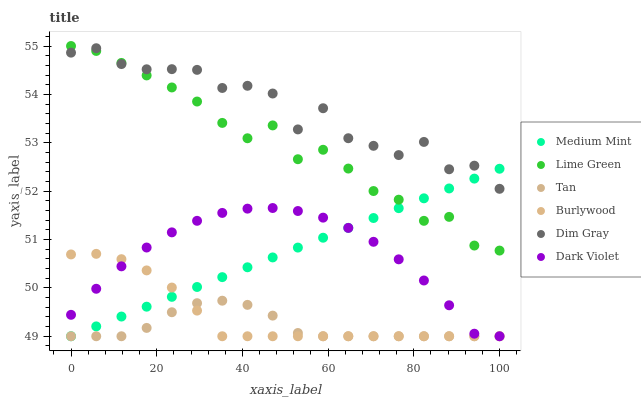Does Tan have the minimum area under the curve?
Answer yes or no. Yes. Does Dim Gray have the maximum area under the curve?
Answer yes or no. Yes. Does Burlywood have the minimum area under the curve?
Answer yes or no. No. Does Burlywood have the maximum area under the curve?
Answer yes or no. No. Is Medium Mint the smoothest?
Answer yes or no. Yes. Is Dim Gray the roughest?
Answer yes or no. Yes. Is Burlywood the smoothest?
Answer yes or no. No. Is Burlywood the roughest?
Answer yes or no. No. Does Medium Mint have the lowest value?
Answer yes or no. Yes. Does Dim Gray have the lowest value?
Answer yes or no. No. Does Lime Green have the highest value?
Answer yes or no. Yes. Does Dim Gray have the highest value?
Answer yes or no. No. Is Burlywood less than Lime Green?
Answer yes or no. Yes. Is Dim Gray greater than Dark Violet?
Answer yes or no. Yes. Does Tan intersect Dark Violet?
Answer yes or no. Yes. Is Tan less than Dark Violet?
Answer yes or no. No. Is Tan greater than Dark Violet?
Answer yes or no. No. Does Burlywood intersect Lime Green?
Answer yes or no. No. 